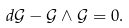<formula> <loc_0><loc_0><loc_500><loc_500>d \mathcal { G } - \mathcal { G } \wedge \mathcal { G } = 0 .</formula> 